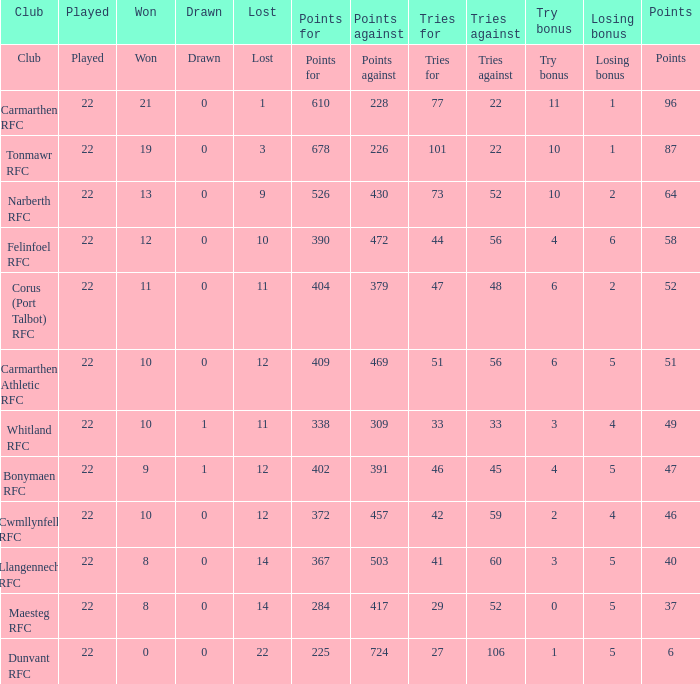What is the loss bonus for 27? 5.0. 